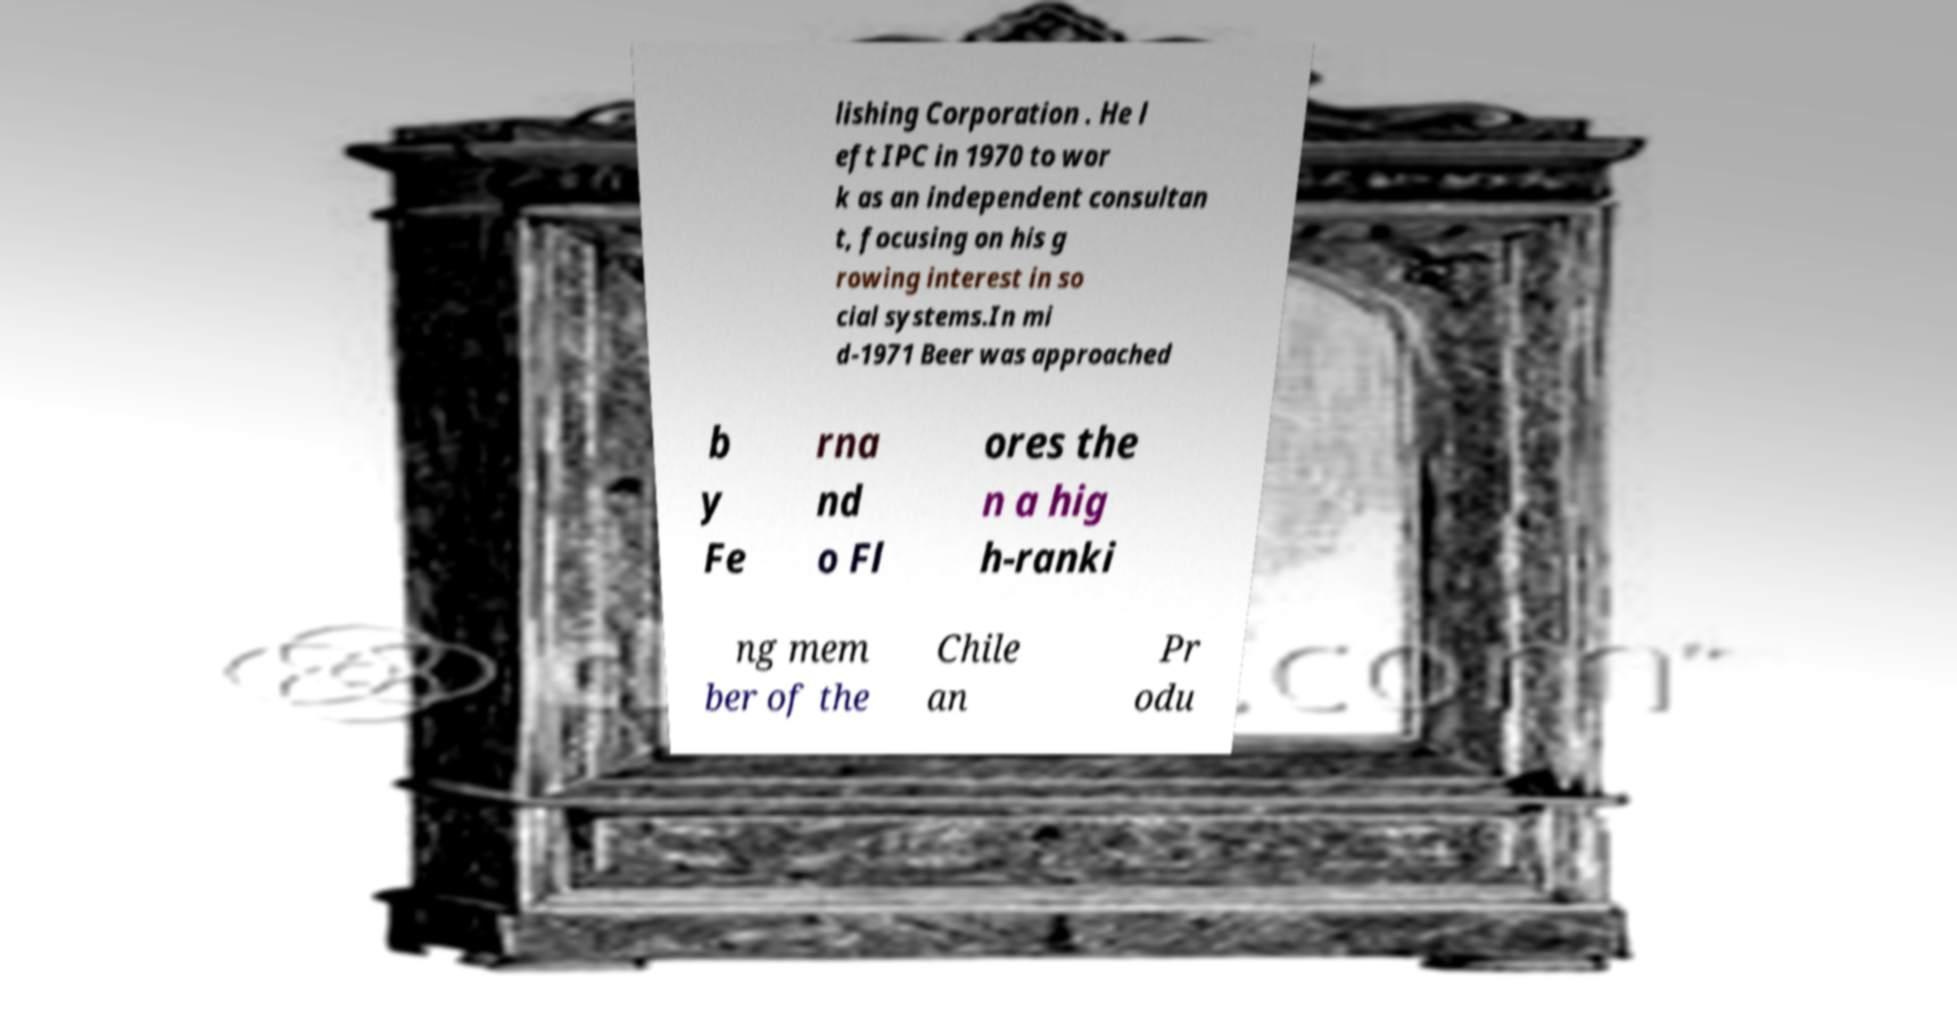Could you assist in decoding the text presented in this image and type it out clearly? lishing Corporation . He l eft IPC in 1970 to wor k as an independent consultan t, focusing on his g rowing interest in so cial systems.In mi d-1971 Beer was approached b y Fe rna nd o Fl ores the n a hig h-ranki ng mem ber of the Chile an Pr odu 